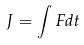Convert formula to latex. <formula><loc_0><loc_0><loc_500><loc_500>J = \int F d t</formula> 